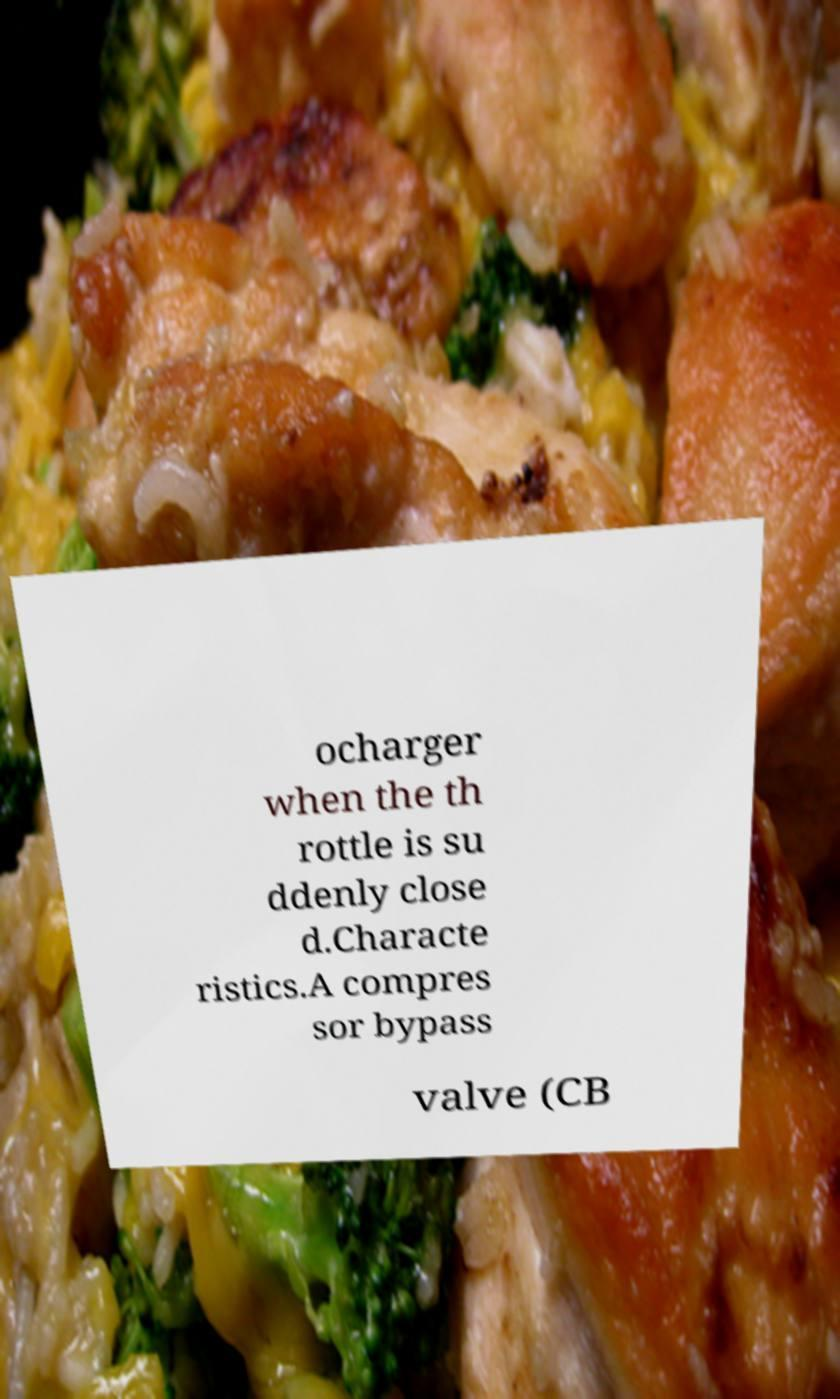There's text embedded in this image that I need extracted. Can you transcribe it verbatim? ocharger when the th rottle is su ddenly close d.Characte ristics.A compres sor bypass valve (CB 